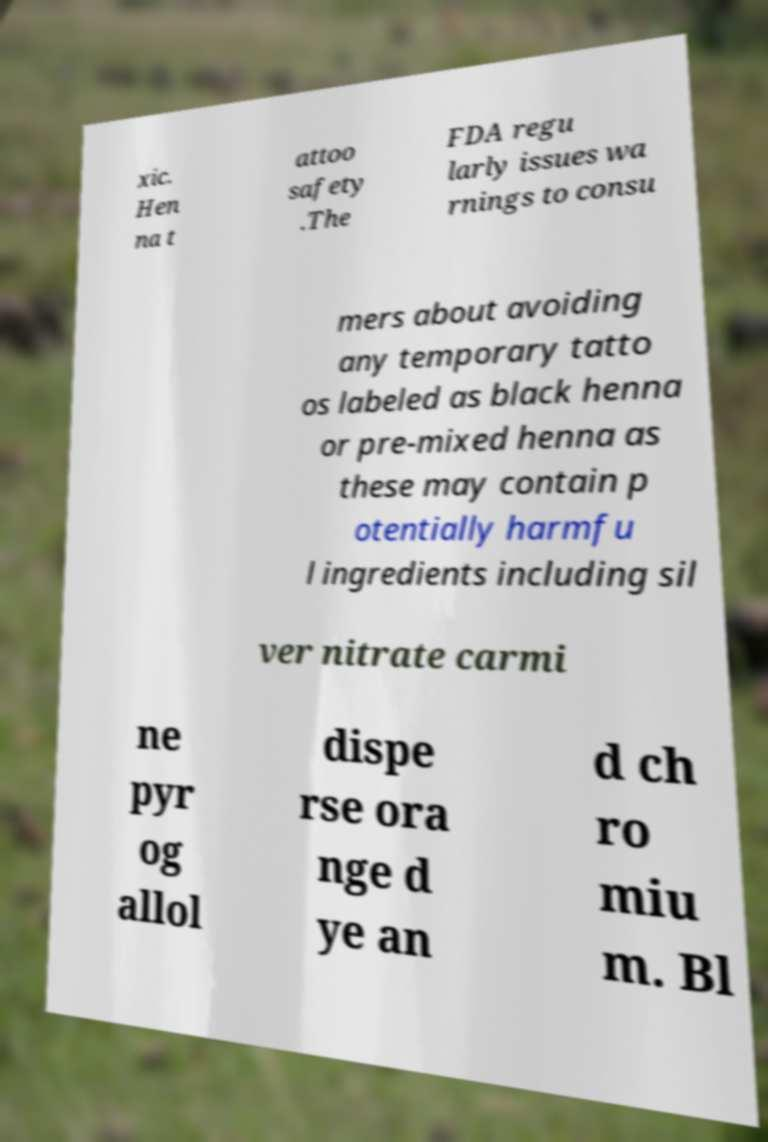What messages or text are displayed in this image? I need them in a readable, typed format. xic. Hen na t attoo safety .The FDA regu larly issues wa rnings to consu mers about avoiding any temporary tatto os labeled as black henna or pre-mixed henna as these may contain p otentially harmfu l ingredients including sil ver nitrate carmi ne pyr og allol dispe rse ora nge d ye an d ch ro miu m. Bl 